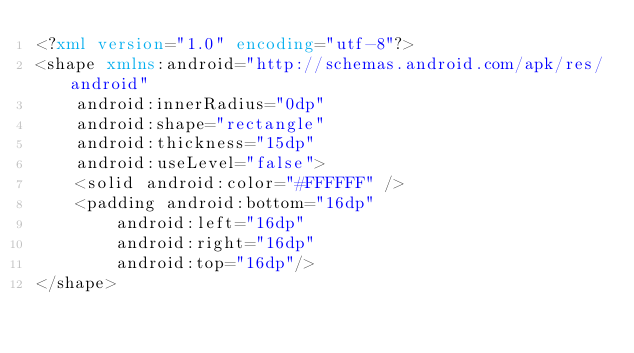Convert code to text. <code><loc_0><loc_0><loc_500><loc_500><_XML_><?xml version="1.0" encoding="utf-8"?>
<shape xmlns:android="http://schemas.android.com/apk/res/android"
    android:innerRadius="0dp"
    android:shape="rectangle"
    android:thickness="15dp"
    android:useLevel="false">
    <solid android:color="#FFFFFF" />
    <padding android:bottom="16dp"
        android:left="16dp"
        android:right="16dp"
        android:top="16dp"/>
</shape></code> 